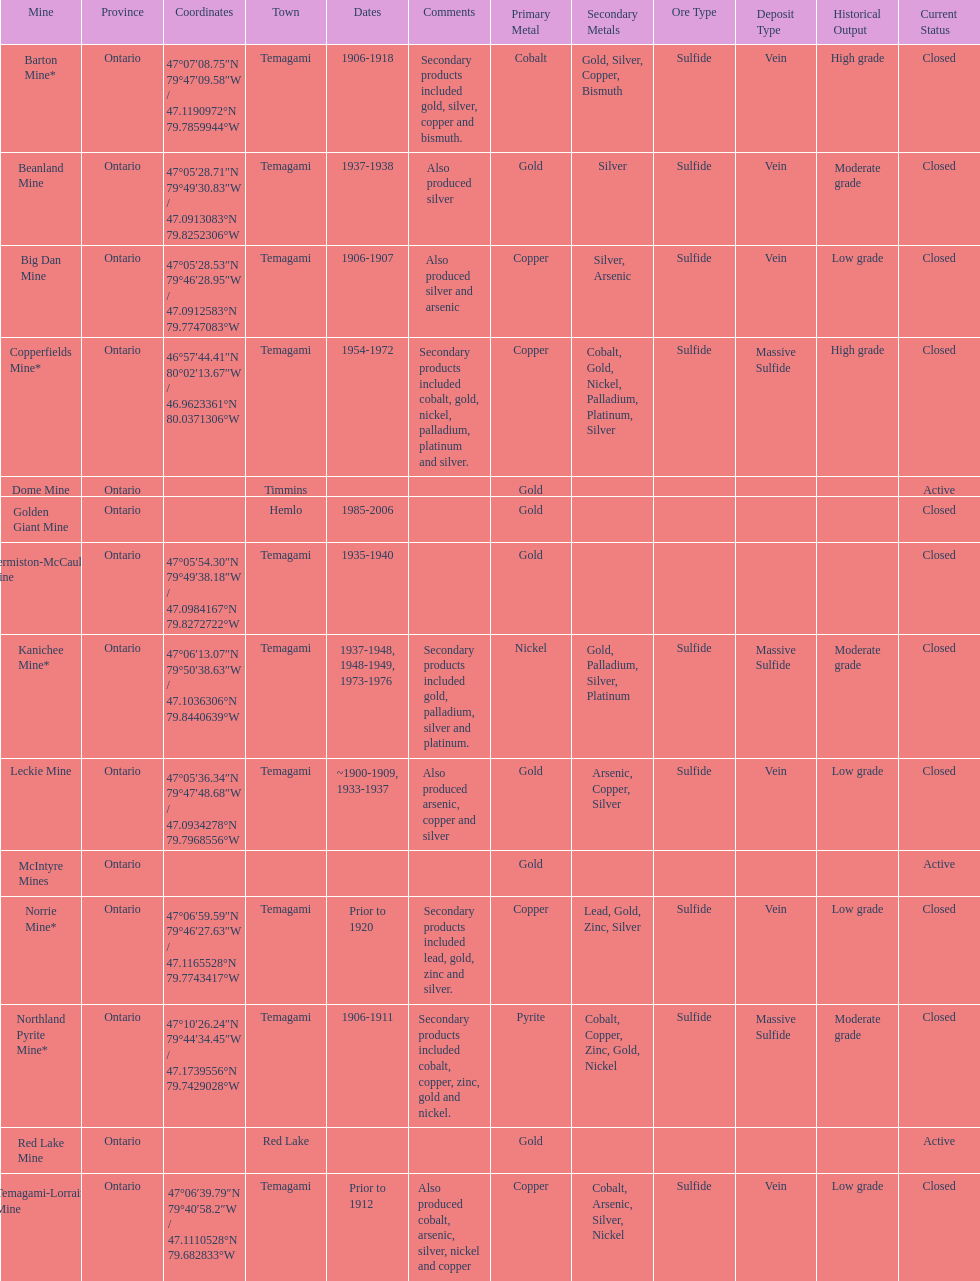How many times is temagami listedon the list? 10. 